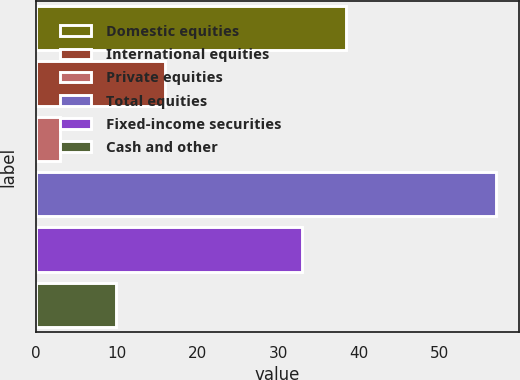Convert chart to OTSL. <chart><loc_0><loc_0><loc_500><loc_500><bar_chart><fcel>Domestic equities<fcel>International equities<fcel>Private equities<fcel>Total equities<fcel>Fixed-income securities<fcel>Cash and other<nl><fcel>38.4<fcel>16<fcel>3<fcel>57<fcel>33<fcel>10<nl></chart> 